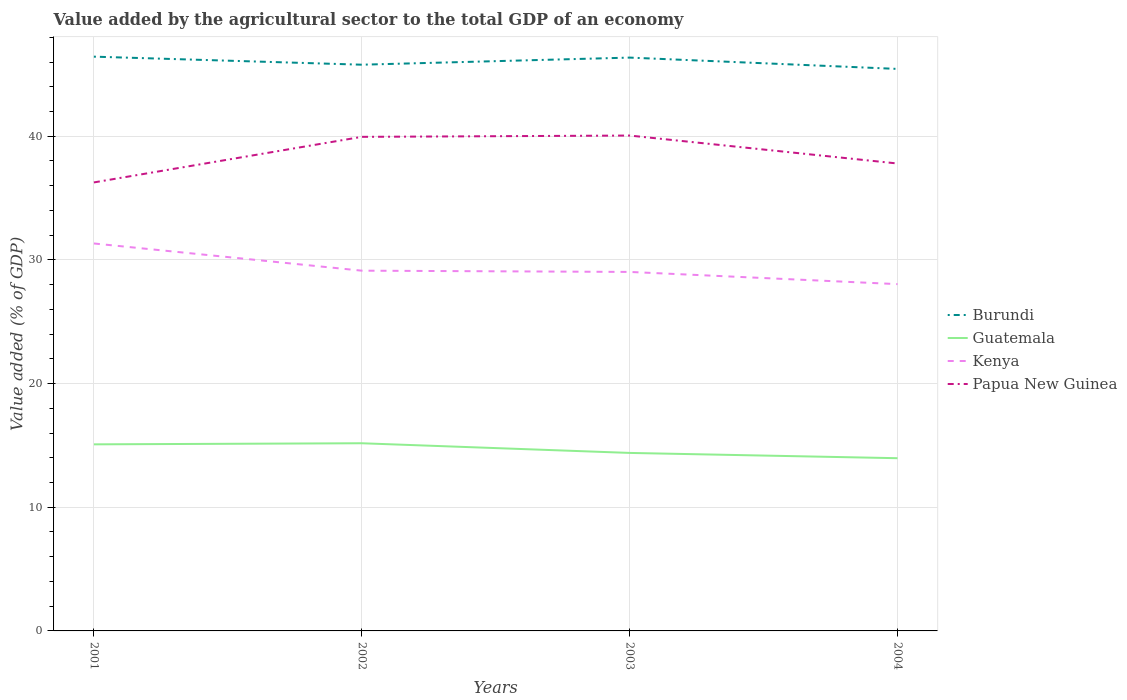How many different coloured lines are there?
Offer a terse response. 4. Is the number of lines equal to the number of legend labels?
Offer a terse response. Yes. Across all years, what is the maximum value added by the agricultural sector to the total GDP in Burundi?
Keep it short and to the point. 45.44. What is the total value added by the agricultural sector to the total GDP in Guatemala in the graph?
Your answer should be very brief. 0.69. What is the difference between the highest and the second highest value added by the agricultural sector to the total GDP in Guatemala?
Make the answer very short. 1.21. What is the difference between the highest and the lowest value added by the agricultural sector to the total GDP in Guatemala?
Provide a succinct answer. 2. Is the value added by the agricultural sector to the total GDP in Kenya strictly greater than the value added by the agricultural sector to the total GDP in Burundi over the years?
Offer a terse response. Yes. Are the values on the major ticks of Y-axis written in scientific E-notation?
Give a very brief answer. No. Does the graph contain any zero values?
Give a very brief answer. No. Where does the legend appear in the graph?
Your response must be concise. Center right. How many legend labels are there?
Your answer should be compact. 4. What is the title of the graph?
Give a very brief answer. Value added by the agricultural sector to the total GDP of an economy. What is the label or title of the X-axis?
Give a very brief answer. Years. What is the label or title of the Y-axis?
Your response must be concise. Value added (% of GDP). What is the Value added (% of GDP) of Burundi in 2001?
Give a very brief answer. 46.44. What is the Value added (% of GDP) of Guatemala in 2001?
Keep it short and to the point. 15.09. What is the Value added (% of GDP) in Kenya in 2001?
Ensure brevity in your answer.  31.33. What is the Value added (% of GDP) in Papua New Guinea in 2001?
Ensure brevity in your answer.  36.27. What is the Value added (% of GDP) in Burundi in 2002?
Give a very brief answer. 45.79. What is the Value added (% of GDP) in Guatemala in 2002?
Ensure brevity in your answer.  15.17. What is the Value added (% of GDP) of Kenya in 2002?
Make the answer very short. 29.13. What is the Value added (% of GDP) of Papua New Guinea in 2002?
Keep it short and to the point. 39.95. What is the Value added (% of GDP) of Burundi in 2003?
Offer a terse response. 46.36. What is the Value added (% of GDP) of Guatemala in 2003?
Your answer should be compact. 14.39. What is the Value added (% of GDP) of Kenya in 2003?
Ensure brevity in your answer.  29.03. What is the Value added (% of GDP) of Papua New Guinea in 2003?
Offer a terse response. 40.06. What is the Value added (% of GDP) in Burundi in 2004?
Your answer should be very brief. 45.44. What is the Value added (% of GDP) in Guatemala in 2004?
Ensure brevity in your answer.  13.97. What is the Value added (% of GDP) in Kenya in 2004?
Ensure brevity in your answer.  28.04. What is the Value added (% of GDP) in Papua New Guinea in 2004?
Keep it short and to the point. 37.8. Across all years, what is the maximum Value added (% of GDP) of Burundi?
Provide a short and direct response. 46.44. Across all years, what is the maximum Value added (% of GDP) of Guatemala?
Offer a terse response. 15.17. Across all years, what is the maximum Value added (% of GDP) of Kenya?
Offer a terse response. 31.33. Across all years, what is the maximum Value added (% of GDP) of Papua New Guinea?
Your answer should be very brief. 40.06. Across all years, what is the minimum Value added (% of GDP) in Burundi?
Offer a very short reply. 45.44. Across all years, what is the minimum Value added (% of GDP) in Guatemala?
Give a very brief answer. 13.97. Across all years, what is the minimum Value added (% of GDP) in Kenya?
Give a very brief answer. 28.04. Across all years, what is the minimum Value added (% of GDP) in Papua New Guinea?
Give a very brief answer. 36.27. What is the total Value added (% of GDP) of Burundi in the graph?
Your answer should be very brief. 184.03. What is the total Value added (% of GDP) in Guatemala in the graph?
Make the answer very short. 58.62. What is the total Value added (% of GDP) of Kenya in the graph?
Offer a terse response. 117.53. What is the total Value added (% of GDP) of Papua New Guinea in the graph?
Your answer should be compact. 154.07. What is the difference between the Value added (% of GDP) in Burundi in 2001 and that in 2002?
Keep it short and to the point. 0.65. What is the difference between the Value added (% of GDP) of Guatemala in 2001 and that in 2002?
Make the answer very short. -0.09. What is the difference between the Value added (% of GDP) of Kenya in 2001 and that in 2002?
Give a very brief answer. 2.2. What is the difference between the Value added (% of GDP) in Papua New Guinea in 2001 and that in 2002?
Ensure brevity in your answer.  -3.68. What is the difference between the Value added (% of GDP) of Burundi in 2001 and that in 2003?
Give a very brief answer. 0.08. What is the difference between the Value added (% of GDP) of Guatemala in 2001 and that in 2003?
Keep it short and to the point. 0.69. What is the difference between the Value added (% of GDP) in Kenya in 2001 and that in 2003?
Ensure brevity in your answer.  2.3. What is the difference between the Value added (% of GDP) of Papua New Guinea in 2001 and that in 2003?
Ensure brevity in your answer.  -3.79. What is the difference between the Value added (% of GDP) in Burundi in 2001 and that in 2004?
Provide a short and direct response. 0.99. What is the difference between the Value added (% of GDP) in Guatemala in 2001 and that in 2004?
Ensure brevity in your answer.  1.12. What is the difference between the Value added (% of GDP) of Kenya in 2001 and that in 2004?
Keep it short and to the point. 3.29. What is the difference between the Value added (% of GDP) in Papua New Guinea in 2001 and that in 2004?
Your answer should be compact. -1.53. What is the difference between the Value added (% of GDP) in Burundi in 2002 and that in 2003?
Your answer should be compact. -0.57. What is the difference between the Value added (% of GDP) of Guatemala in 2002 and that in 2003?
Provide a short and direct response. 0.78. What is the difference between the Value added (% of GDP) of Kenya in 2002 and that in 2003?
Provide a succinct answer. 0.1. What is the difference between the Value added (% of GDP) of Papua New Guinea in 2002 and that in 2003?
Offer a terse response. -0.11. What is the difference between the Value added (% of GDP) in Burundi in 2002 and that in 2004?
Make the answer very short. 0.34. What is the difference between the Value added (% of GDP) of Guatemala in 2002 and that in 2004?
Provide a short and direct response. 1.21. What is the difference between the Value added (% of GDP) in Kenya in 2002 and that in 2004?
Offer a very short reply. 1.09. What is the difference between the Value added (% of GDP) in Papua New Guinea in 2002 and that in 2004?
Provide a short and direct response. 2.16. What is the difference between the Value added (% of GDP) of Burundi in 2003 and that in 2004?
Offer a very short reply. 0.92. What is the difference between the Value added (% of GDP) of Guatemala in 2003 and that in 2004?
Your answer should be compact. 0.43. What is the difference between the Value added (% of GDP) of Kenya in 2003 and that in 2004?
Provide a succinct answer. 0.99. What is the difference between the Value added (% of GDP) in Papua New Guinea in 2003 and that in 2004?
Keep it short and to the point. 2.26. What is the difference between the Value added (% of GDP) in Burundi in 2001 and the Value added (% of GDP) in Guatemala in 2002?
Offer a very short reply. 31.26. What is the difference between the Value added (% of GDP) of Burundi in 2001 and the Value added (% of GDP) of Kenya in 2002?
Ensure brevity in your answer.  17.31. What is the difference between the Value added (% of GDP) of Burundi in 2001 and the Value added (% of GDP) of Papua New Guinea in 2002?
Ensure brevity in your answer.  6.49. What is the difference between the Value added (% of GDP) in Guatemala in 2001 and the Value added (% of GDP) in Kenya in 2002?
Your answer should be very brief. -14.04. What is the difference between the Value added (% of GDP) in Guatemala in 2001 and the Value added (% of GDP) in Papua New Guinea in 2002?
Give a very brief answer. -24.86. What is the difference between the Value added (% of GDP) in Kenya in 2001 and the Value added (% of GDP) in Papua New Guinea in 2002?
Your answer should be very brief. -8.62. What is the difference between the Value added (% of GDP) of Burundi in 2001 and the Value added (% of GDP) of Guatemala in 2003?
Your answer should be compact. 32.04. What is the difference between the Value added (% of GDP) in Burundi in 2001 and the Value added (% of GDP) in Kenya in 2003?
Ensure brevity in your answer.  17.41. What is the difference between the Value added (% of GDP) in Burundi in 2001 and the Value added (% of GDP) in Papua New Guinea in 2003?
Give a very brief answer. 6.38. What is the difference between the Value added (% of GDP) in Guatemala in 2001 and the Value added (% of GDP) in Kenya in 2003?
Provide a short and direct response. -13.94. What is the difference between the Value added (% of GDP) in Guatemala in 2001 and the Value added (% of GDP) in Papua New Guinea in 2003?
Provide a short and direct response. -24.97. What is the difference between the Value added (% of GDP) of Kenya in 2001 and the Value added (% of GDP) of Papua New Guinea in 2003?
Your answer should be compact. -8.73. What is the difference between the Value added (% of GDP) of Burundi in 2001 and the Value added (% of GDP) of Guatemala in 2004?
Ensure brevity in your answer.  32.47. What is the difference between the Value added (% of GDP) of Burundi in 2001 and the Value added (% of GDP) of Kenya in 2004?
Ensure brevity in your answer.  18.39. What is the difference between the Value added (% of GDP) in Burundi in 2001 and the Value added (% of GDP) in Papua New Guinea in 2004?
Your response must be concise. 8.64. What is the difference between the Value added (% of GDP) of Guatemala in 2001 and the Value added (% of GDP) of Kenya in 2004?
Keep it short and to the point. -12.96. What is the difference between the Value added (% of GDP) in Guatemala in 2001 and the Value added (% of GDP) in Papua New Guinea in 2004?
Your response must be concise. -22.71. What is the difference between the Value added (% of GDP) in Kenya in 2001 and the Value added (% of GDP) in Papua New Guinea in 2004?
Offer a terse response. -6.47. What is the difference between the Value added (% of GDP) of Burundi in 2002 and the Value added (% of GDP) of Guatemala in 2003?
Offer a very short reply. 31.39. What is the difference between the Value added (% of GDP) in Burundi in 2002 and the Value added (% of GDP) in Kenya in 2003?
Your answer should be very brief. 16.76. What is the difference between the Value added (% of GDP) in Burundi in 2002 and the Value added (% of GDP) in Papua New Guinea in 2003?
Offer a terse response. 5.73. What is the difference between the Value added (% of GDP) in Guatemala in 2002 and the Value added (% of GDP) in Kenya in 2003?
Offer a terse response. -13.85. What is the difference between the Value added (% of GDP) of Guatemala in 2002 and the Value added (% of GDP) of Papua New Guinea in 2003?
Make the answer very short. -24.88. What is the difference between the Value added (% of GDP) in Kenya in 2002 and the Value added (% of GDP) in Papua New Guinea in 2003?
Provide a succinct answer. -10.93. What is the difference between the Value added (% of GDP) of Burundi in 2002 and the Value added (% of GDP) of Guatemala in 2004?
Make the answer very short. 31.82. What is the difference between the Value added (% of GDP) in Burundi in 2002 and the Value added (% of GDP) in Kenya in 2004?
Provide a short and direct response. 17.74. What is the difference between the Value added (% of GDP) of Burundi in 2002 and the Value added (% of GDP) of Papua New Guinea in 2004?
Offer a very short reply. 7.99. What is the difference between the Value added (% of GDP) in Guatemala in 2002 and the Value added (% of GDP) in Kenya in 2004?
Keep it short and to the point. -12.87. What is the difference between the Value added (% of GDP) of Guatemala in 2002 and the Value added (% of GDP) of Papua New Guinea in 2004?
Provide a short and direct response. -22.62. What is the difference between the Value added (% of GDP) of Kenya in 2002 and the Value added (% of GDP) of Papua New Guinea in 2004?
Keep it short and to the point. -8.67. What is the difference between the Value added (% of GDP) of Burundi in 2003 and the Value added (% of GDP) of Guatemala in 2004?
Provide a short and direct response. 32.39. What is the difference between the Value added (% of GDP) of Burundi in 2003 and the Value added (% of GDP) of Kenya in 2004?
Your answer should be very brief. 18.32. What is the difference between the Value added (% of GDP) in Burundi in 2003 and the Value added (% of GDP) in Papua New Guinea in 2004?
Provide a succinct answer. 8.56. What is the difference between the Value added (% of GDP) of Guatemala in 2003 and the Value added (% of GDP) of Kenya in 2004?
Provide a succinct answer. -13.65. What is the difference between the Value added (% of GDP) of Guatemala in 2003 and the Value added (% of GDP) of Papua New Guinea in 2004?
Offer a terse response. -23.4. What is the difference between the Value added (% of GDP) in Kenya in 2003 and the Value added (% of GDP) in Papua New Guinea in 2004?
Provide a short and direct response. -8.77. What is the average Value added (% of GDP) in Burundi per year?
Your answer should be compact. 46.01. What is the average Value added (% of GDP) of Guatemala per year?
Give a very brief answer. 14.66. What is the average Value added (% of GDP) of Kenya per year?
Your answer should be compact. 29.38. What is the average Value added (% of GDP) of Papua New Guinea per year?
Your answer should be compact. 38.52. In the year 2001, what is the difference between the Value added (% of GDP) of Burundi and Value added (% of GDP) of Guatemala?
Ensure brevity in your answer.  31.35. In the year 2001, what is the difference between the Value added (% of GDP) of Burundi and Value added (% of GDP) of Kenya?
Ensure brevity in your answer.  15.11. In the year 2001, what is the difference between the Value added (% of GDP) in Burundi and Value added (% of GDP) in Papua New Guinea?
Offer a very short reply. 10.17. In the year 2001, what is the difference between the Value added (% of GDP) in Guatemala and Value added (% of GDP) in Kenya?
Provide a short and direct response. -16.24. In the year 2001, what is the difference between the Value added (% of GDP) in Guatemala and Value added (% of GDP) in Papua New Guinea?
Make the answer very short. -21.18. In the year 2001, what is the difference between the Value added (% of GDP) in Kenya and Value added (% of GDP) in Papua New Guinea?
Give a very brief answer. -4.94. In the year 2002, what is the difference between the Value added (% of GDP) of Burundi and Value added (% of GDP) of Guatemala?
Give a very brief answer. 30.61. In the year 2002, what is the difference between the Value added (% of GDP) of Burundi and Value added (% of GDP) of Kenya?
Offer a terse response. 16.66. In the year 2002, what is the difference between the Value added (% of GDP) of Burundi and Value added (% of GDP) of Papua New Guinea?
Make the answer very short. 5.83. In the year 2002, what is the difference between the Value added (% of GDP) of Guatemala and Value added (% of GDP) of Kenya?
Provide a short and direct response. -13.96. In the year 2002, what is the difference between the Value added (% of GDP) in Guatemala and Value added (% of GDP) in Papua New Guinea?
Ensure brevity in your answer.  -24.78. In the year 2002, what is the difference between the Value added (% of GDP) of Kenya and Value added (% of GDP) of Papua New Guinea?
Provide a short and direct response. -10.82. In the year 2003, what is the difference between the Value added (% of GDP) in Burundi and Value added (% of GDP) in Guatemala?
Provide a short and direct response. 31.97. In the year 2003, what is the difference between the Value added (% of GDP) of Burundi and Value added (% of GDP) of Kenya?
Give a very brief answer. 17.33. In the year 2003, what is the difference between the Value added (% of GDP) in Burundi and Value added (% of GDP) in Papua New Guinea?
Offer a very short reply. 6.3. In the year 2003, what is the difference between the Value added (% of GDP) in Guatemala and Value added (% of GDP) in Kenya?
Provide a succinct answer. -14.64. In the year 2003, what is the difference between the Value added (% of GDP) of Guatemala and Value added (% of GDP) of Papua New Guinea?
Provide a succinct answer. -25.66. In the year 2003, what is the difference between the Value added (% of GDP) in Kenya and Value added (% of GDP) in Papua New Guinea?
Ensure brevity in your answer.  -11.03. In the year 2004, what is the difference between the Value added (% of GDP) of Burundi and Value added (% of GDP) of Guatemala?
Offer a very short reply. 31.48. In the year 2004, what is the difference between the Value added (% of GDP) of Burundi and Value added (% of GDP) of Kenya?
Your response must be concise. 17.4. In the year 2004, what is the difference between the Value added (% of GDP) of Burundi and Value added (% of GDP) of Papua New Guinea?
Your answer should be compact. 7.65. In the year 2004, what is the difference between the Value added (% of GDP) in Guatemala and Value added (% of GDP) in Kenya?
Make the answer very short. -14.08. In the year 2004, what is the difference between the Value added (% of GDP) of Guatemala and Value added (% of GDP) of Papua New Guinea?
Make the answer very short. -23.83. In the year 2004, what is the difference between the Value added (% of GDP) of Kenya and Value added (% of GDP) of Papua New Guinea?
Provide a succinct answer. -9.75. What is the ratio of the Value added (% of GDP) of Burundi in 2001 to that in 2002?
Give a very brief answer. 1.01. What is the ratio of the Value added (% of GDP) of Kenya in 2001 to that in 2002?
Give a very brief answer. 1.08. What is the ratio of the Value added (% of GDP) of Papua New Guinea in 2001 to that in 2002?
Provide a short and direct response. 0.91. What is the ratio of the Value added (% of GDP) of Burundi in 2001 to that in 2003?
Ensure brevity in your answer.  1. What is the ratio of the Value added (% of GDP) in Guatemala in 2001 to that in 2003?
Give a very brief answer. 1.05. What is the ratio of the Value added (% of GDP) of Kenya in 2001 to that in 2003?
Your response must be concise. 1.08. What is the ratio of the Value added (% of GDP) of Papua New Guinea in 2001 to that in 2003?
Your response must be concise. 0.91. What is the ratio of the Value added (% of GDP) in Burundi in 2001 to that in 2004?
Your answer should be very brief. 1.02. What is the ratio of the Value added (% of GDP) in Guatemala in 2001 to that in 2004?
Keep it short and to the point. 1.08. What is the ratio of the Value added (% of GDP) in Kenya in 2001 to that in 2004?
Your response must be concise. 1.12. What is the ratio of the Value added (% of GDP) of Papua New Guinea in 2001 to that in 2004?
Provide a short and direct response. 0.96. What is the ratio of the Value added (% of GDP) of Burundi in 2002 to that in 2003?
Ensure brevity in your answer.  0.99. What is the ratio of the Value added (% of GDP) in Guatemala in 2002 to that in 2003?
Give a very brief answer. 1.05. What is the ratio of the Value added (% of GDP) of Kenya in 2002 to that in 2003?
Your answer should be very brief. 1. What is the ratio of the Value added (% of GDP) in Papua New Guinea in 2002 to that in 2003?
Offer a terse response. 1. What is the ratio of the Value added (% of GDP) in Burundi in 2002 to that in 2004?
Keep it short and to the point. 1.01. What is the ratio of the Value added (% of GDP) of Guatemala in 2002 to that in 2004?
Offer a very short reply. 1.09. What is the ratio of the Value added (% of GDP) in Kenya in 2002 to that in 2004?
Offer a very short reply. 1.04. What is the ratio of the Value added (% of GDP) in Papua New Guinea in 2002 to that in 2004?
Your answer should be very brief. 1.06. What is the ratio of the Value added (% of GDP) of Burundi in 2003 to that in 2004?
Your answer should be very brief. 1.02. What is the ratio of the Value added (% of GDP) of Guatemala in 2003 to that in 2004?
Offer a terse response. 1.03. What is the ratio of the Value added (% of GDP) of Kenya in 2003 to that in 2004?
Provide a succinct answer. 1.04. What is the ratio of the Value added (% of GDP) in Papua New Guinea in 2003 to that in 2004?
Give a very brief answer. 1.06. What is the difference between the highest and the second highest Value added (% of GDP) of Burundi?
Provide a succinct answer. 0.08. What is the difference between the highest and the second highest Value added (% of GDP) of Guatemala?
Give a very brief answer. 0.09. What is the difference between the highest and the second highest Value added (% of GDP) in Kenya?
Make the answer very short. 2.2. What is the difference between the highest and the second highest Value added (% of GDP) of Papua New Guinea?
Offer a very short reply. 0.11. What is the difference between the highest and the lowest Value added (% of GDP) of Burundi?
Provide a short and direct response. 0.99. What is the difference between the highest and the lowest Value added (% of GDP) of Guatemala?
Make the answer very short. 1.21. What is the difference between the highest and the lowest Value added (% of GDP) in Kenya?
Give a very brief answer. 3.29. What is the difference between the highest and the lowest Value added (% of GDP) of Papua New Guinea?
Keep it short and to the point. 3.79. 